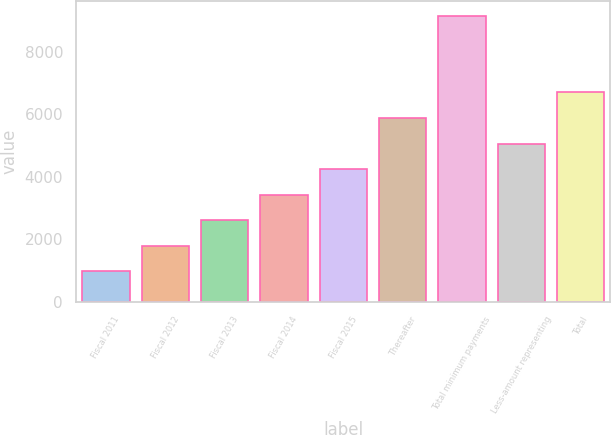Convert chart. <chart><loc_0><loc_0><loc_500><loc_500><bar_chart><fcel>Fiscal 2011<fcel>Fiscal 2012<fcel>Fiscal 2013<fcel>Fiscal 2014<fcel>Fiscal 2015<fcel>Thereafter<fcel>Total minimum payments<fcel>Less-amount representing<fcel>Total<nl><fcel>982<fcel>1797.9<fcel>2613.8<fcel>3429.7<fcel>4245.6<fcel>5877.4<fcel>9141<fcel>5061.5<fcel>6693.3<nl></chart> 